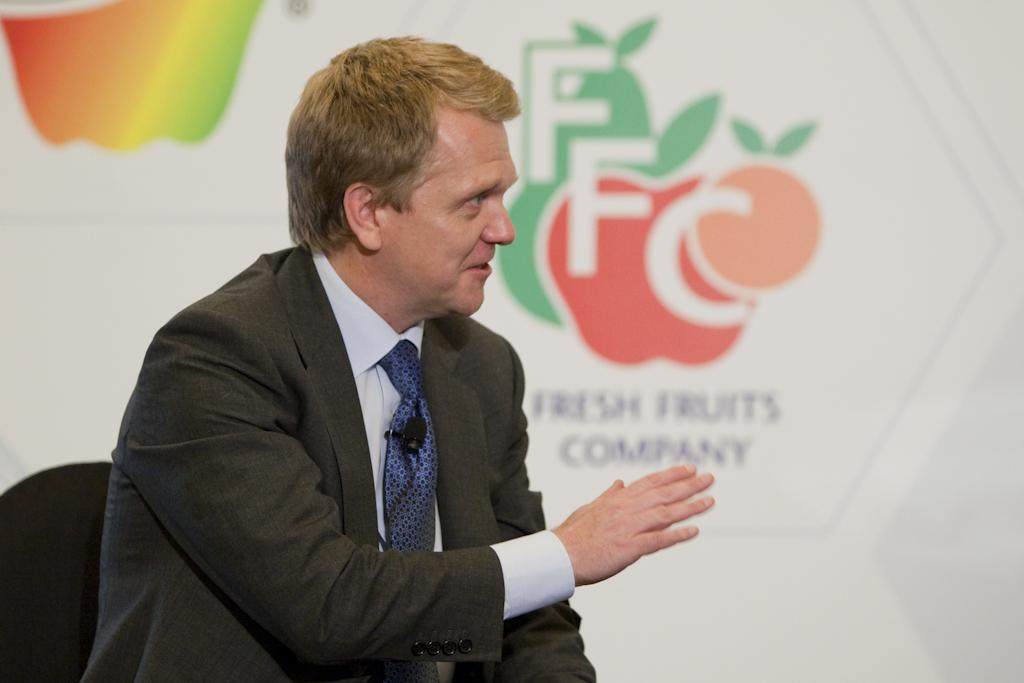What is the main subject of the image? There is a person sitting on a chair in the image. Can you describe the person's position or activity? The person is sitting on a chair, but their specific activity is not mentioned in the facts. What can be seen in the background of the image? There is a poster with images and text in the background of the image. What type of needle is being used by the person in the image? There is no needle present in the image. How does the person in the image capture the attention of the audience? The facts provided do not mention any audience or the person's ability to capture attention. Can you describe the condition of the person's tooth in the image? There is no mention of a tooth or any dental-related information in the facts provided. 